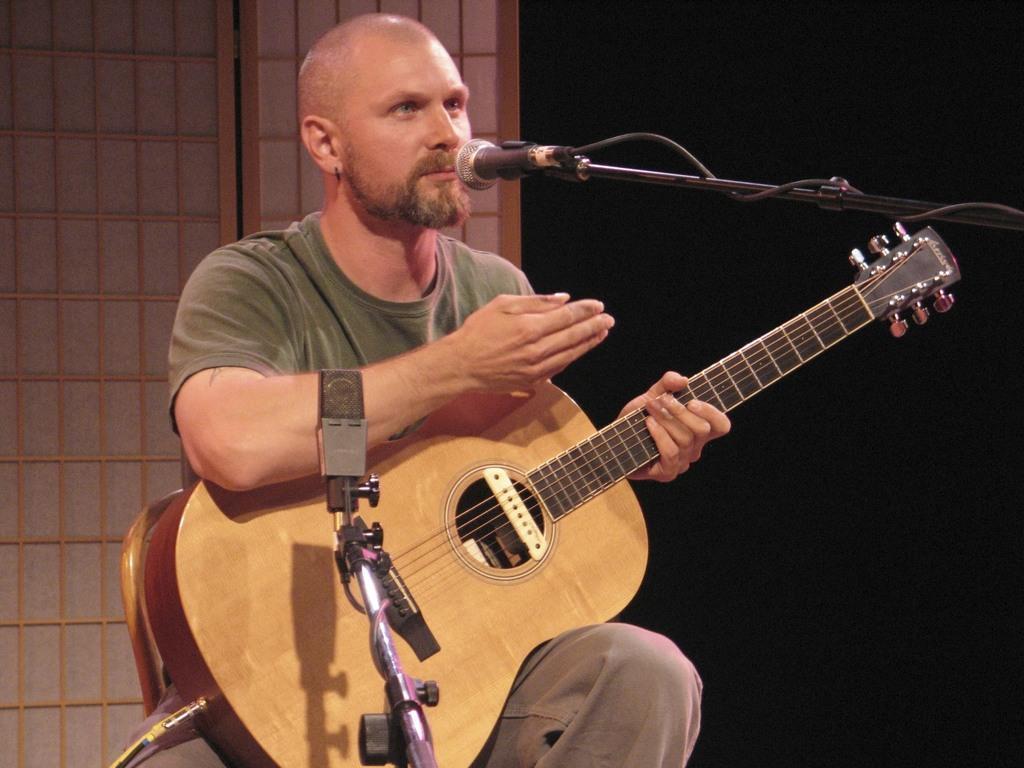Can you describe this image briefly? A man is singing with a mic in front of him while holding a guitar in his hand. 